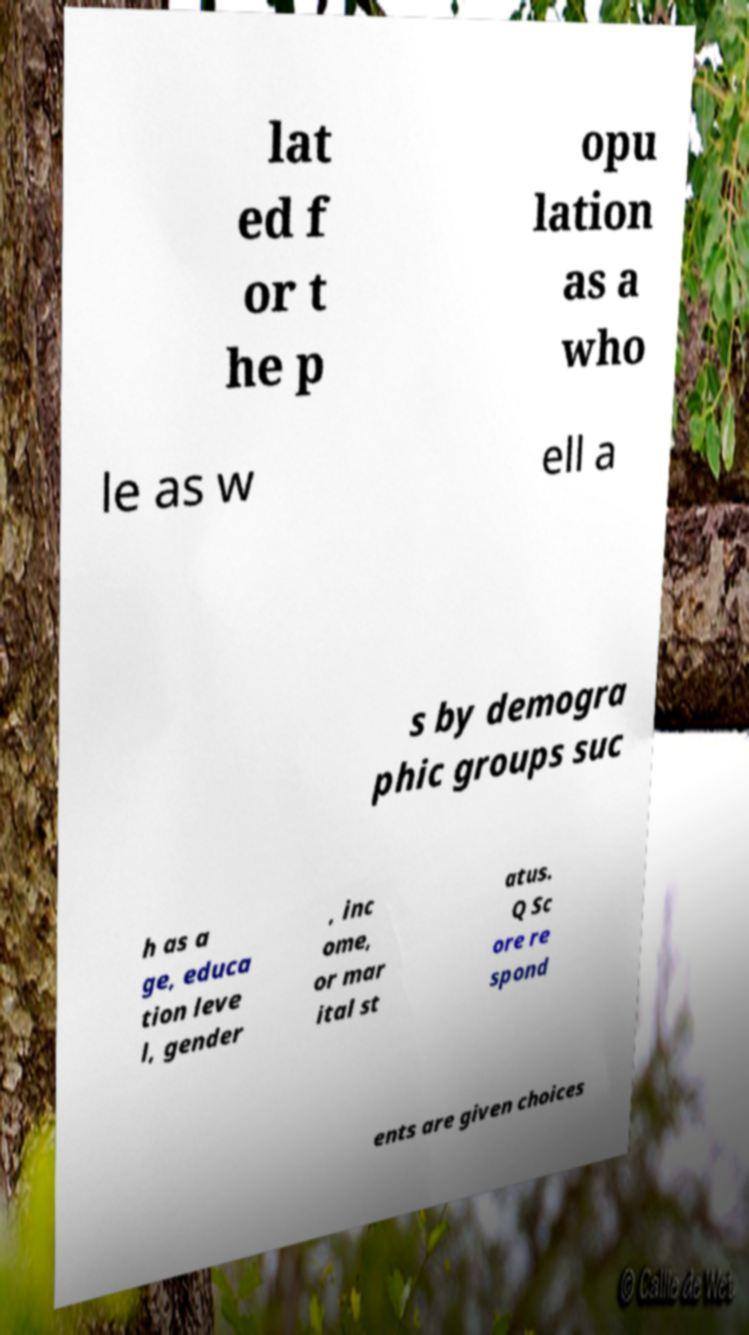Could you assist in decoding the text presented in this image and type it out clearly? lat ed f or t he p opu lation as a who le as w ell a s by demogra phic groups suc h as a ge, educa tion leve l, gender , inc ome, or mar ital st atus. Q Sc ore re spond ents are given choices 